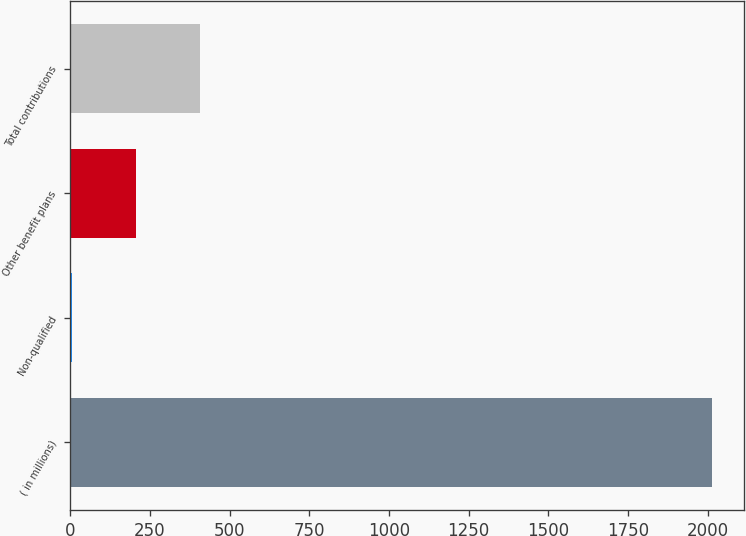<chart> <loc_0><loc_0><loc_500><loc_500><bar_chart><fcel>( in millions)<fcel>Non-qualified<fcel>Other benefit plans<fcel>Total contributions<nl><fcel>2013<fcel>4<fcel>204.9<fcel>405.8<nl></chart> 